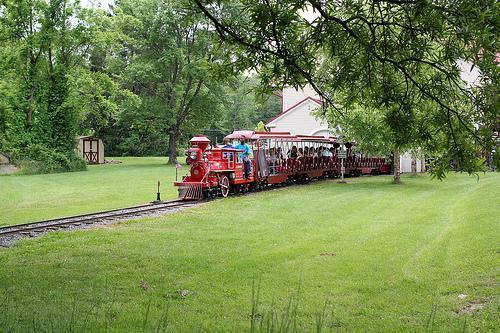How many adults are operating the train?
Give a very brief answer. 2. 